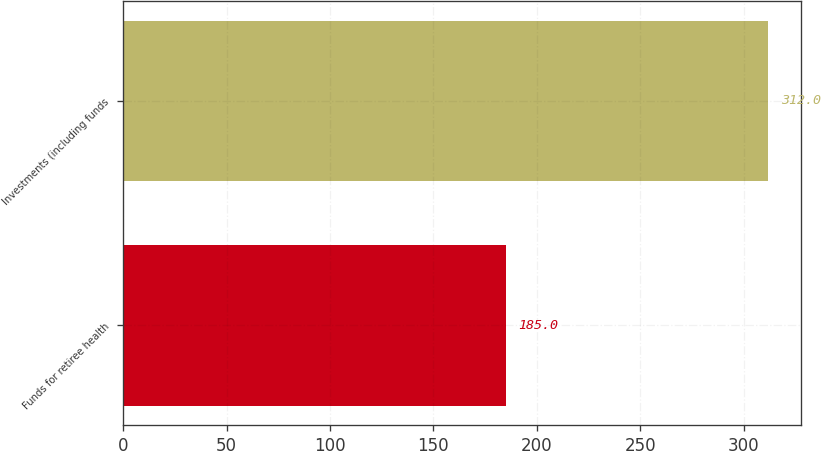Convert chart. <chart><loc_0><loc_0><loc_500><loc_500><bar_chart><fcel>Funds for retiree health<fcel>Investments (including funds<nl><fcel>185<fcel>312<nl></chart> 